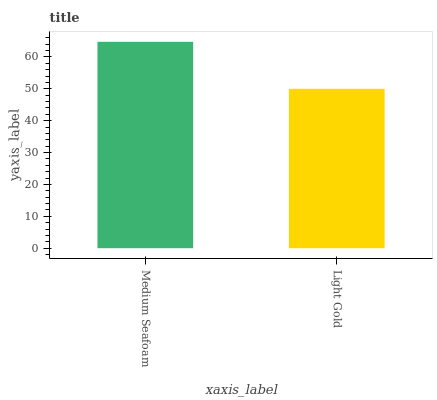Is Light Gold the minimum?
Answer yes or no. Yes. Is Medium Seafoam the maximum?
Answer yes or no. Yes. Is Light Gold the maximum?
Answer yes or no. No. Is Medium Seafoam greater than Light Gold?
Answer yes or no. Yes. Is Light Gold less than Medium Seafoam?
Answer yes or no. Yes. Is Light Gold greater than Medium Seafoam?
Answer yes or no. No. Is Medium Seafoam less than Light Gold?
Answer yes or no. No. Is Medium Seafoam the high median?
Answer yes or no. Yes. Is Light Gold the low median?
Answer yes or no. Yes. Is Light Gold the high median?
Answer yes or no. No. Is Medium Seafoam the low median?
Answer yes or no. No. 